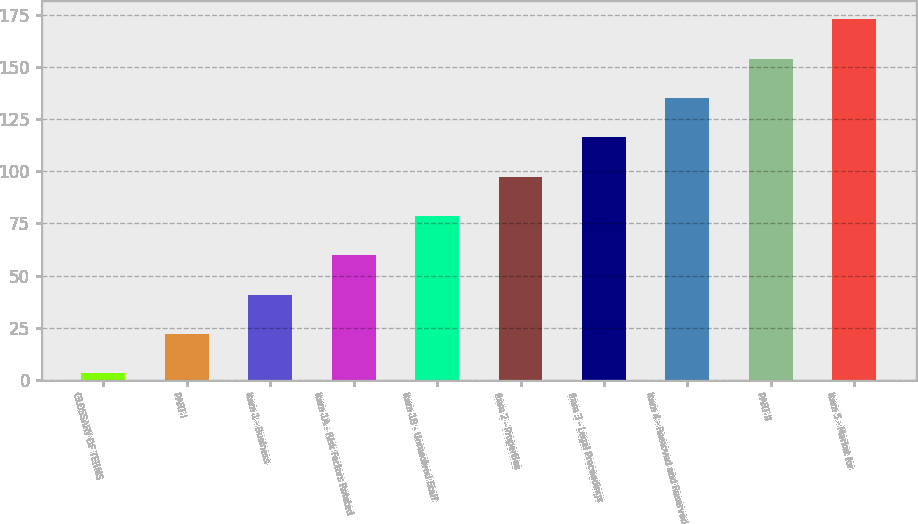Convert chart. <chart><loc_0><loc_0><loc_500><loc_500><bar_chart><fcel>GLOSSARY OF TERMS<fcel>PART I<fcel>Item 1 - Business<fcel>Item 1A - Risk Factors Related<fcel>Item 1B - Unresolved Staff<fcel>Item 2 - Properties<fcel>Item 3 - Legal Proceedings<fcel>Item 4 - Removed and Reserved<fcel>PART II<fcel>Item 5 - Market for<nl><fcel>3<fcel>21.9<fcel>40.8<fcel>59.7<fcel>78.6<fcel>97.5<fcel>116.4<fcel>135.3<fcel>154.2<fcel>173.1<nl></chart> 